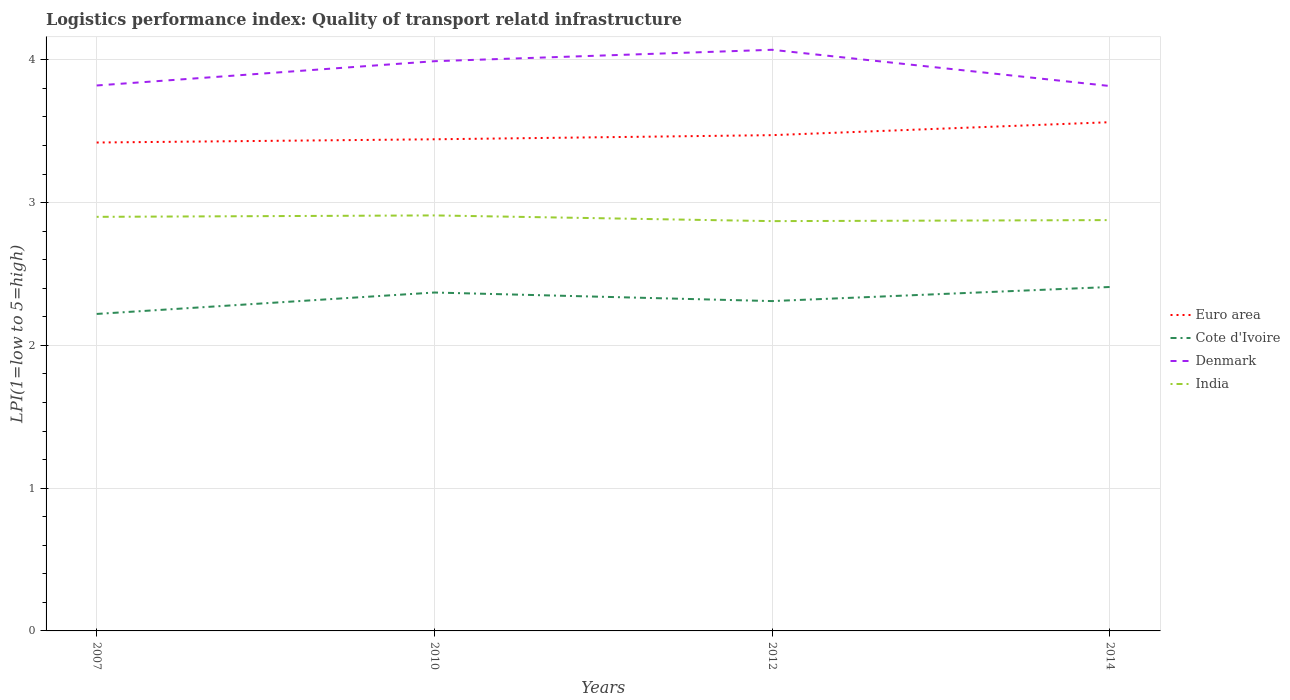How many different coloured lines are there?
Give a very brief answer. 4. Is the number of lines equal to the number of legend labels?
Keep it short and to the point. Yes. Across all years, what is the maximum logistics performance index in India?
Ensure brevity in your answer.  2.87. What is the total logistics performance index in Euro area in the graph?
Your answer should be very brief. -0.09. What is the difference between the highest and the second highest logistics performance index in Cote d'Ivoire?
Offer a very short reply. 0.19. What is the difference between the highest and the lowest logistics performance index in India?
Your answer should be compact. 2. Is the logistics performance index in Cote d'Ivoire strictly greater than the logistics performance index in Euro area over the years?
Your response must be concise. Yes. What is the difference between two consecutive major ticks on the Y-axis?
Your answer should be compact. 1. Does the graph contain grids?
Give a very brief answer. Yes. Where does the legend appear in the graph?
Your answer should be very brief. Center right. How many legend labels are there?
Your answer should be compact. 4. How are the legend labels stacked?
Provide a short and direct response. Vertical. What is the title of the graph?
Offer a terse response. Logistics performance index: Quality of transport relatd infrastructure. Does "Luxembourg" appear as one of the legend labels in the graph?
Provide a short and direct response. No. What is the label or title of the Y-axis?
Your response must be concise. LPI(1=low to 5=high). What is the LPI(1=low to 5=high) in Euro area in 2007?
Provide a succinct answer. 3.42. What is the LPI(1=low to 5=high) in Cote d'Ivoire in 2007?
Offer a terse response. 2.22. What is the LPI(1=low to 5=high) of Denmark in 2007?
Offer a very short reply. 3.82. What is the LPI(1=low to 5=high) in Euro area in 2010?
Your answer should be very brief. 3.44. What is the LPI(1=low to 5=high) of Cote d'Ivoire in 2010?
Offer a very short reply. 2.37. What is the LPI(1=low to 5=high) in Denmark in 2010?
Offer a terse response. 3.99. What is the LPI(1=low to 5=high) of India in 2010?
Offer a terse response. 2.91. What is the LPI(1=low to 5=high) of Euro area in 2012?
Offer a very short reply. 3.47. What is the LPI(1=low to 5=high) of Cote d'Ivoire in 2012?
Your response must be concise. 2.31. What is the LPI(1=low to 5=high) of Denmark in 2012?
Your answer should be compact. 4.07. What is the LPI(1=low to 5=high) in India in 2012?
Your answer should be compact. 2.87. What is the LPI(1=low to 5=high) of Euro area in 2014?
Ensure brevity in your answer.  3.56. What is the LPI(1=low to 5=high) of Cote d'Ivoire in 2014?
Your answer should be compact. 2.41. What is the LPI(1=low to 5=high) of Denmark in 2014?
Your answer should be very brief. 3.82. What is the LPI(1=low to 5=high) in India in 2014?
Offer a terse response. 2.88. Across all years, what is the maximum LPI(1=low to 5=high) of Euro area?
Offer a terse response. 3.56. Across all years, what is the maximum LPI(1=low to 5=high) of Cote d'Ivoire?
Your answer should be very brief. 2.41. Across all years, what is the maximum LPI(1=low to 5=high) in Denmark?
Give a very brief answer. 4.07. Across all years, what is the maximum LPI(1=low to 5=high) of India?
Provide a short and direct response. 2.91. Across all years, what is the minimum LPI(1=low to 5=high) of Euro area?
Make the answer very short. 3.42. Across all years, what is the minimum LPI(1=low to 5=high) of Cote d'Ivoire?
Give a very brief answer. 2.22. Across all years, what is the minimum LPI(1=low to 5=high) of Denmark?
Offer a terse response. 3.82. Across all years, what is the minimum LPI(1=low to 5=high) of India?
Keep it short and to the point. 2.87. What is the total LPI(1=low to 5=high) of Euro area in the graph?
Your answer should be compact. 13.9. What is the total LPI(1=low to 5=high) of Cote d'Ivoire in the graph?
Provide a succinct answer. 9.31. What is the total LPI(1=low to 5=high) in Denmark in the graph?
Offer a very short reply. 15.7. What is the total LPI(1=low to 5=high) of India in the graph?
Keep it short and to the point. 11.56. What is the difference between the LPI(1=low to 5=high) of Euro area in 2007 and that in 2010?
Your response must be concise. -0.02. What is the difference between the LPI(1=low to 5=high) of Cote d'Ivoire in 2007 and that in 2010?
Offer a terse response. -0.15. What is the difference between the LPI(1=low to 5=high) of Denmark in 2007 and that in 2010?
Offer a terse response. -0.17. What is the difference between the LPI(1=low to 5=high) of India in 2007 and that in 2010?
Your response must be concise. -0.01. What is the difference between the LPI(1=low to 5=high) of Euro area in 2007 and that in 2012?
Offer a very short reply. -0.05. What is the difference between the LPI(1=low to 5=high) in Cote d'Ivoire in 2007 and that in 2012?
Give a very brief answer. -0.09. What is the difference between the LPI(1=low to 5=high) in Denmark in 2007 and that in 2012?
Offer a very short reply. -0.25. What is the difference between the LPI(1=low to 5=high) in Euro area in 2007 and that in 2014?
Provide a succinct answer. -0.14. What is the difference between the LPI(1=low to 5=high) of Cote d'Ivoire in 2007 and that in 2014?
Offer a terse response. -0.19. What is the difference between the LPI(1=low to 5=high) in Denmark in 2007 and that in 2014?
Offer a very short reply. 0. What is the difference between the LPI(1=low to 5=high) of India in 2007 and that in 2014?
Ensure brevity in your answer.  0.02. What is the difference between the LPI(1=low to 5=high) in Euro area in 2010 and that in 2012?
Offer a terse response. -0.03. What is the difference between the LPI(1=low to 5=high) of Cote d'Ivoire in 2010 and that in 2012?
Offer a terse response. 0.06. What is the difference between the LPI(1=low to 5=high) of Denmark in 2010 and that in 2012?
Your answer should be very brief. -0.08. What is the difference between the LPI(1=low to 5=high) of Euro area in 2010 and that in 2014?
Provide a short and direct response. -0.12. What is the difference between the LPI(1=low to 5=high) in Cote d'Ivoire in 2010 and that in 2014?
Offer a terse response. -0.04. What is the difference between the LPI(1=low to 5=high) of Denmark in 2010 and that in 2014?
Offer a very short reply. 0.17. What is the difference between the LPI(1=low to 5=high) of India in 2010 and that in 2014?
Your answer should be compact. 0.03. What is the difference between the LPI(1=low to 5=high) of Euro area in 2012 and that in 2014?
Ensure brevity in your answer.  -0.09. What is the difference between the LPI(1=low to 5=high) of Cote d'Ivoire in 2012 and that in 2014?
Offer a terse response. -0.1. What is the difference between the LPI(1=low to 5=high) in Denmark in 2012 and that in 2014?
Your response must be concise. 0.25. What is the difference between the LPI(1=low to 5=high) of India in 2012 and that in 2014?
Your answer should be compact. -0.01. What is the difference between the LPI(1=low to 5=high) of Euro area in 2007 and the LPI(1=low to 5=high) of Cote d'Ivoire in 2010?
Offer a terse response. 1.05. What is the difference between the LPI(1=low to 5=high) in Euro area in 2007 and the LPI(1=low to 5=high) in Denmark in 2010?
Your response must be concise. -0.57. What is the difference between the LPI(1=low to 5=high) in Euro area in 2007 and the LPI(1=low to 5=high) in India in 2010?
Provide a short and direct response. 0.51. What is the difference between the LPI(1=low to 5=high) of Cote d'Ivoire in 2007 and the LPI(1=low to 5=high) of Denmark in 2010?
Keep it short and to the point. -1.77. What is the difference between the LPI(1=low to 5=high) of Cote d'Ivoire in 2007 and the LPI(1=low to 5=high) of India in 2010?
Give a very brief answer. -0.69. What is the difference between the LPI(1=low to 5=high) of Denmark in 2007 and the LPI(1=low to 5=high) of India in 2010?
Make the answer very short. 0.91. What is the difference between the LPI(1=low to 5=high) of Euro area in 2007 and the LPI(1=low to 5=high) of Cote d'Ivoire in 2012?
Your response must be concise. 1.11. What is the difference between the LPI(1=low to 5=high) of Euro area in 2007 and the LPI(1=low to 5=high) of Denmark in 2012?
Ensure brevity in your answer.  -0.65. What is the difference between the LPI(1=low to 5=high) in Euro area in 2007 and the LPI(1=low to 5=high) in India in 2012?
Make the answer very short. 0.55. What is the difference between the LPI(1=low to 5=high) of Cote d'Ivoire in 2007 and the LPI(1=low to 5=high) of Denmark in 2012?
Offer a terse response. -1.85. What is the difference between the LPI(1=low to 5=high) in Cote d'Ivoire in 2007 and the LPI(1=low to 5=high) in India in 2012?
Your answer should be compact. -0.65. What is the difference between the LPI(1=low to 5=high) of Denmark in 2007 and the LPI(1=low to 5=high) of India in 2012?
Offer a terse response. 0.95. What is the difference between the LPI(1=low to 5=high) of Euro area in 2007 and the LPI(1=low to 5=high) of Cote d'Ivoire in 2014?
Keep it short and to the point. 1.01. What is the difference between the LPI(1=low to 5=high) of Euro area in 2007 and the LPI(1=low to 5=high) of Denmark in 2014?
Your response must be concise. -0.4. What is the difference between the LPI(1=low to 5=high) of Euro area in 2007 and the LPI(1=low to 5=high) of India in 2014?
Provide a succinct answer. 0.54. What is the difference between the LPI(1=low to 5=high) of Cote d'Ivoire in 2007 and the LPI(1=low to 5=high) of Denmark in 2014?
Make the answer very short. -1.6. What is the difference between the LPI(1=low to 5=high) of Cote d'Ivoire in 2007 and the LPI(1=low to 5=high) of India in 2014?
Give a very brief answer. -0.66. What is the difference between the LPI(1=low to 5=high) of Denmark in 2007 and the LPI(1=low to 5=high) of India in 2014?
Offer a very short reply. 0.94. What is the difference between the LPI(1=low to 5=high) of Euro area in 2010 and the LPI(1=low to 5=high) of Cote d'Ivoire in 2012?
Ensure brevity in your answer.  1.13. What is the difference between the LPI(1=low to 5=high) of Euro area in 2010 and the LPI(1=low to 5=high) of Denmark in 2012?
Your answer should be very brief. -0.63. What is the difference between the LPI(1=low to 5=high) in Euro area in 2010 and the LPI(1=low to 5=high) in India in 2012?
Ensure brevity in your answer.  0.57. What is the difference between the LPI(1=low to 5=high) in Cote d'Ivoire in 2010 and the LPI(1=low to 5=high) in Denmark in 2012?
Provide a succinct answer. -1.7. What is the difference between the LPI(1=low to 5=high) in Denmark in 2010 and the LPI(1=low to 5=high) in India in 2012?
Give a very brief answer. 1.12. What is the difference between the LPI(1=low to 5=high) in Euro area in 2010 and the LPI(1=low to 5=high) in Cote d'Ivoire in 2014?
Your response must be concise. 1.03. What is the difference between the LPI(1=low to 5=high) in Euro area in 2010 and the LPI(1=low to 5=high) in Denmark in 2014?
Your response must be concise. -0.37. What is the difference between the LPI(1=low to 5=high) in Euro area in 2010 and the LPI(1=low to 5=high) in India in 2014?
Provide a short and direct response. 0.57. What is the difference between the LPI(1=low to 5=high) of Cote d'Ivoire in 2010 and the LPI(1=low to 5=high) of Denmark in 2014?
Keep it short and to the point. -1.45. What is the difference between the LPI(1=low to 5=high) in Cote d'Ivoire in 2010 and the LPI(1=low to 5=high) in India in 2014?
Your answer should be very brief. -0.51. What is the difference between the LPI(1=low to 5=high) of Denmark in 2010 and the LPI(1=low to 5=high) of India in 2014?
Offer a very short reply. 1.11. What is the difference between the LPI(1=low to 5=high) in Euro area in 2012 and the LPI(1=low to 5=high) in Cote d'Ivoire in 2014?
Your answer should be compact. 1.06. What is the difference between the LPI(1=low to 5=high) of Euro area in 2012 and the LPI(1=low to 5=high) of Denmark in 2014?
Provide a short and direct response. -0.34. What is the difference between the LPI(1=low to 5=high) in Euro area in 2012 and the LPI(1=low to 5=high) in India in 2014?
Ensure brevity in your answer.  0.59. What is the difference between the LPI(1=low to 5=high) of Cote d'Ivoire in 2012 and the LPI(1=low to 5=high) of Denmark in 2014?
Offer a terse response. -1.51. What is the difference between the LPI(1=low to 5=high) of Cote d'Ivoire in 2012 and the LPI(1=low to 5=high) of India in 2014?
Your answer should be very brief. -0.57. What is the difference between the LPI(1=low to 5=high) of Denmark in 2012 and the LPI(1=low to 5=high) of India in 2014?
Your answer should be compact. 1.19. What is the average LPI(1=low to 5=high) in Euro area per year?
Provide a succinct answer. 3.47. What is the average LPI(1=low to 5=high) in Cote d'Ivoire per year?
Offer a very short reply. 2.33. What is the average LPI(1=low to 5=high) in Denmark per year?
Keep it short and to the point. 3.92. What is the average LPI(1=low to 5=high) of India per year?
Provide a succinct answer. 2.89. In the year 2007, what is the difference between the LPI(1=low to 5=high) in Euro area and LPI(1=low to 5=high) in Cote d'Ivoire?
Offer a very short reply. 1.2. In the year 2007, what is the difference between the LPI(1=low to 5=high) in Euro area and LPI(1=low to 5=high) in Denmark?
Ensure brevity in your answer.  -0.4. In the year 2007, what is the difference between the LPI(1=low to 5=high) of Euro area and LPI(1=low to 5=high) of India?
Give a very brief answer. 0.52. In the year 2007, what is the difference between the LPI(1=low to 5=high) in Cote d'Ivoire and LPI(1=low to 5=high) in Denmark?
Make the answer very short. -1.6. In the year 2007, what is the difference between the LPI(1=low to 5=high) in Cote d'Ivoire and LPI(1=low to 5=high) in India?
Keep it short and to the point. -0.68. In the year 2010, what is the difference between the LPI(1=low to 5=high) of Euro area and LPI(1=low to 5=high) of Cote d'Ivoire?
Your response must be concise. 1.07. In the year 2010, what is the difference between the LPI(1=low to 5=high) of Euro area and LPI(1=low to 5=high) of Denmark?
Your answer should be very brief. -0.55. In the year 2010, what is the difference between the LPI(1=low to 5=high) of Euro area and LPI(1=low to 5=high) of India?
Your answer should be compact. 0.53. In the year 2010, what is the difference between the LPI(1=low to 5=high) in Cote d'Ivoire and LPI(1=low to 5=high) in Denmark?
Offer a terse response. -1.62. In the year 2010, what is the difference between the LPI(1=low to 5=high) in Cote d'Ivoire and LPI(1=low to 5=high) in India?
Your answer should be very brief. -0.54. In the year 2012, what is the difference between the LPI(1=low to 5=high) in Euro area and LPI(1=low to 5=high) in Cote d'Ivoire?
Provide a short and direct response. 1.16. In the year 2012, what is the difference between the LPI(1=low to 5=high) in Euro area and LPI(1=low to 5=high) in Denmark?
Your answer should be compact. -0.6. In the year 2012, what is the difference between the LPI(1=low to 5=high) in Euro area and LPI(1=low to 5=high) in India?
Your response must be concise. 0.6. In the year 2012, what is the difference between the LPI(1=low to 5=high) in Cote d'Ivoire and LPI(1=low to 5=high) in Denmark?
Provide a succinct answer. -1.76. In the year 2012, what is the difference between the LPI(1=low to 5=high) of Cote d'Ivoire and LPI(1=low to 5=high) of India?
Provide a succinct answer. -0.56. In the year 2014, what is the difference between the LPI(1=low to 5=high) in Euro area and LPI(1=low to 5=high) in Cote d'Ivoire?
Provide a succinct answer. 1.15. In the year 2014, what is the difference between the LPI(1=low to 5=high) of Euro area and LPI(1=low to 5=high) of Denmark?
Offer a very short reply. -0.25. In the year 2014, what is the difference between the LPI(1=low to 5=high) in Euro area and LPI(1=low to 5=high) in India?
Your answer should be very brief. 0.69. In the year 2014, what is the difference between the LPI(1=low to 5=high) of Cote d'Ivoire and LPI(1=low to 5=high) of Denmark?
Your answer should be compact. -1.41. In the year 2014, what is the difference between the LPI(1=low to 5=high) of Cote d'Ivoire and LPI(1=low to 5=high) of India?
Make the answer very short. -0.47. In the year 2014, what is the difference between the LPI(1=low to 5=high) in Denmark and LPI(1=low to 5=high) in India?
Your answer should be very brief. 0.94. What is the ratio of the LPI(1=low to 5=high) in Euro area in 2007 to that in 2010?
Keep it short and to the point. 0.99. What is the ratio of the LPI(1=low to 5=high) in Cote d'Ivoire in 2007 to that in 2010?
Give a very brief answer. 0.94. What is the ratio of the LPI(1=low to 5=high) of Denmark in 2007 to that in 2010?
Ensure brevity in your answer.  0.96. What is the ratio of the LPI(1=low to 5=high) in India in 2007 to that in 2010?
Give a very brief answer. 1. What is the ratio of the LPI(1=low to 5=high) in Euro area in 2007 to that in 2012?
Offer a very short reply. 0.99. What is the ratio of the LPI(1=low to 5=high) in Denmark in 2007 to that in 2012?
Provide a short and direct response. 0.94. What is the ratio of the LPI(1=low to 5=high) of India in 2007 to that in 2012?
Ensure brevity in your answer.  1.01. What is the ratio of the LPI(1=low to 5=high) of Euro area in 2007 to that in 2014?
Provide a short and direct response. 0.96. What is the ratio of the LPI(1=low to 5=high) in Cote d'Ivoire in 2007 to that in 2014?
Your response must be concise. 0.92. What is the ratio of the LPI(1=low to 5=high) in Denmark in 2007 to that in 2014?
Offer a terse response. 1. What is the ratio of the LPI(1=low to 5=high) of India in 2007 to that in 2014?
Provide a short and direct response. 1.01. What is the ratio of the LPI(1=low to 5=high) of Cote d'Ivoire in 2010 to that in 2012?
Your response must be concise. 1.03. What is the ratio of the LPI(1=low to 5=high) of Denmark in 2010 to that in 2012?
Provide a short and direct response. 0.98. What is the ratio of the LPI(1=low to 5=high) in India in 2010 to that in 2012?
Give a very brief answer. 1.01. What is the ratio of the LPI(1=low to 5=high) in Euro area in 2010 to that in 2014?
Your response must be concise. 0.97. What is the ratio of the LPI(1=low to 5=high) in Cote d'Ivoire in 2010 to that in 2014?
Offer a terse response. 0.98. What is the ratio of the LPI(1=low to 5=high) of Denmark in 2010 to that in 2014?
Your answer should be very brief. 1.05. What is the ratio of the LPI(1=low to 5=high) of India in 2010 to that in 2014?
Offer a terse response. 1.01. What is the ratio of the LPI(1=low to 5=high) of Euro area in 2012 to that in 2014?
Ensure brevity in your answer.  0.97. What is the ratio of the LPI(1=low to 5=high) of Cote d'Ivoire in 2012 to that in 2014?
Your response must be concise. 0.96. What is the ratio of the LPI(1=low to 5=high) of Denmark in 2012 to that in 2014?
Give a very brief answer. 1.07. What is the difference between the highest and the second highest LPI(1=low to 5=high) in Euro area?
Offer a terse response. 0.09. What is the difference between the highest and the second highest LPI(1=low to 5=high) in Cote d'Ivoire?
Ensure brevity in your answer.  0.04. What is the difference between the highest and the second highest LPI(1=low to 5=high) in India?
Keep it short and to the point. 0.01. What is the difference between the highest and the lowest LPI(1=low to 5=high) in Euro area?
Your response must be concise. 0.14. What is the difference between the highest and the lowest LPI(1=low to 5=high) in Cote d'Ivoire?
Make the answer very short. 0.19. What is the difference between the highest and the lowest LPI(1=low to 5=high) in Denmark?
Your answer should be very brief. 0.25. What is the difference between the highest and the lowest LPI(1=low to 5=high) in India?
Provide a succinct answer. 0.04. 